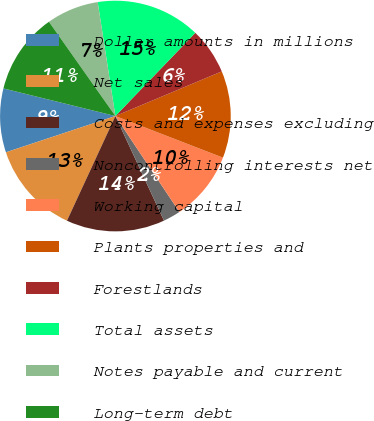Convert chart. <chart><loc_0><loc_0><loc_500><loc_500><pie_chart><fcel>Dollar amounts in millions<fcel>Net sales<fcel>Costs and expenses excluding<fcel>Noncontrolling interests net<fcel>Working capital<fcel>Plants properties and<fcel>Forestlands<fcel>Total assets<fcel>Notes payable and current<fcel>Long-term debt<nl><fcel>8.94%<fcel>13.01%<fcel>13.82%<fcel>2.44%<fcel>9.76%<fcel>12.2%<fcel>6.5%<fcel>14.63%<fcel>7.32%<fcel>11.38%<nl></chart> 